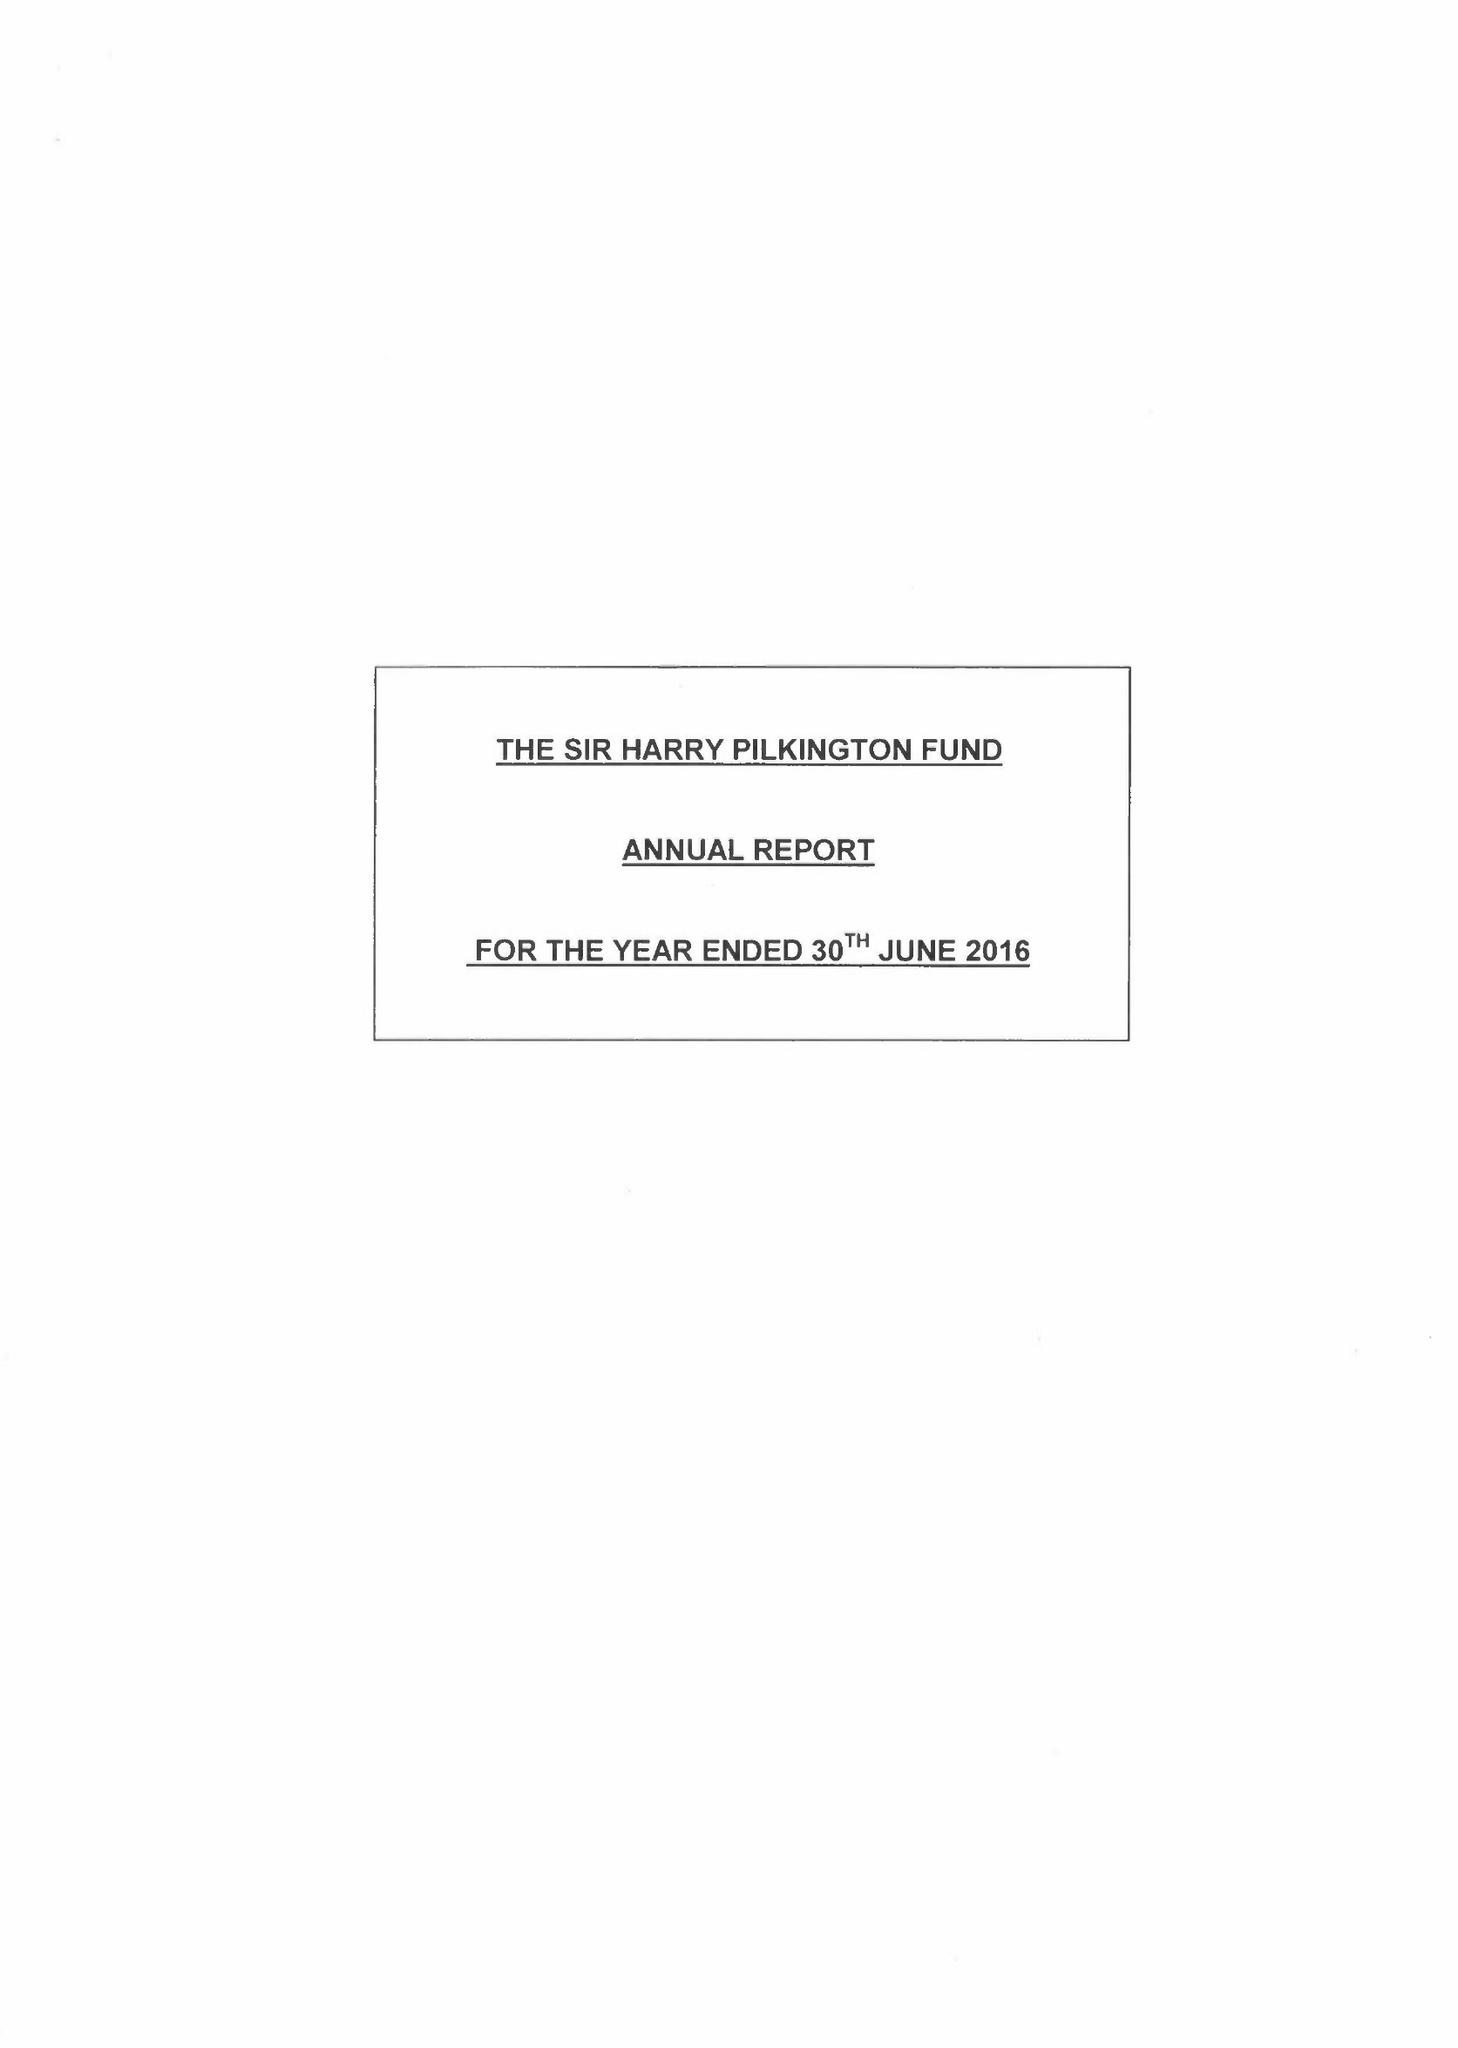What is the value for the income_annually_in_british_pounds?
Answer the question using a single word or phrase. 184527.00 